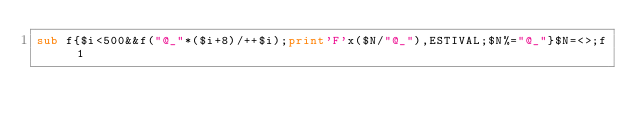Convert code to text. <code><loc_0><loc_0><loc_500><loc_500><_Perl_>sub f{$i<500&&f("@_"*($i+8)/++$i);print'F'x($N/"@_"),ESTIVAL;$N%="@_"}$N=<>;f 1</code> 